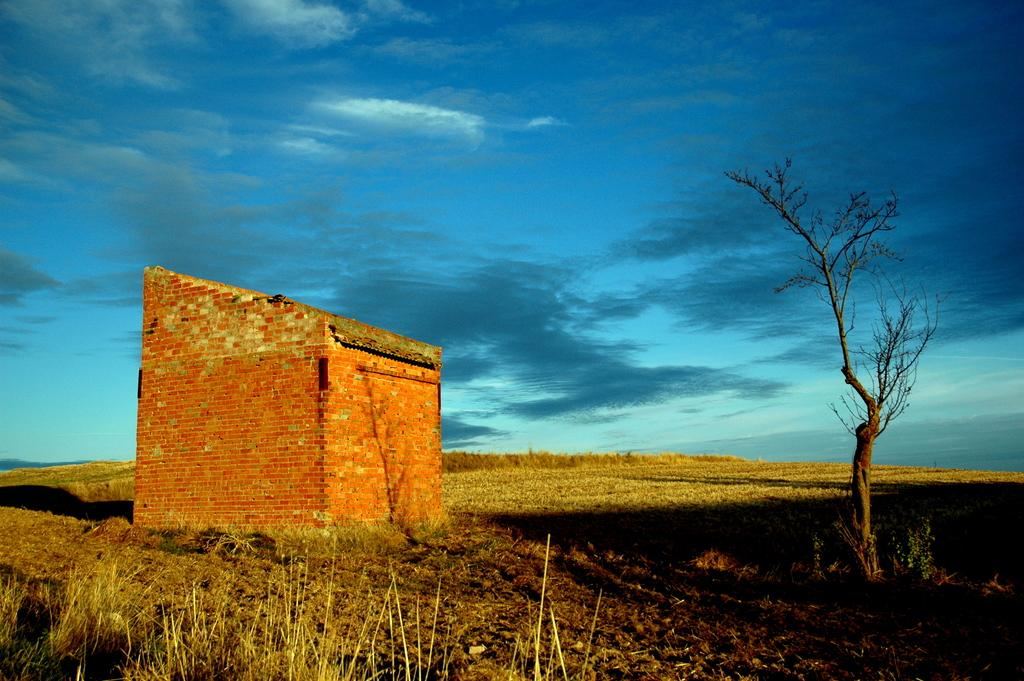What type of terrain is visible in the image? There is a grassy land in the image. What natural element can be seen in the image? There is a tree in the image. How would you describe the sky in the image? The sky is blue with clouds. Where is the brick house located in the image? The brick house is present on the left side of the image. What type of poison is being used by the ducks in the image? There are no ducks present in the image, and therefore no poison can be observed. Can you solve the riddle written on the tree in the image? There is no riddle written on the tree in the image. 